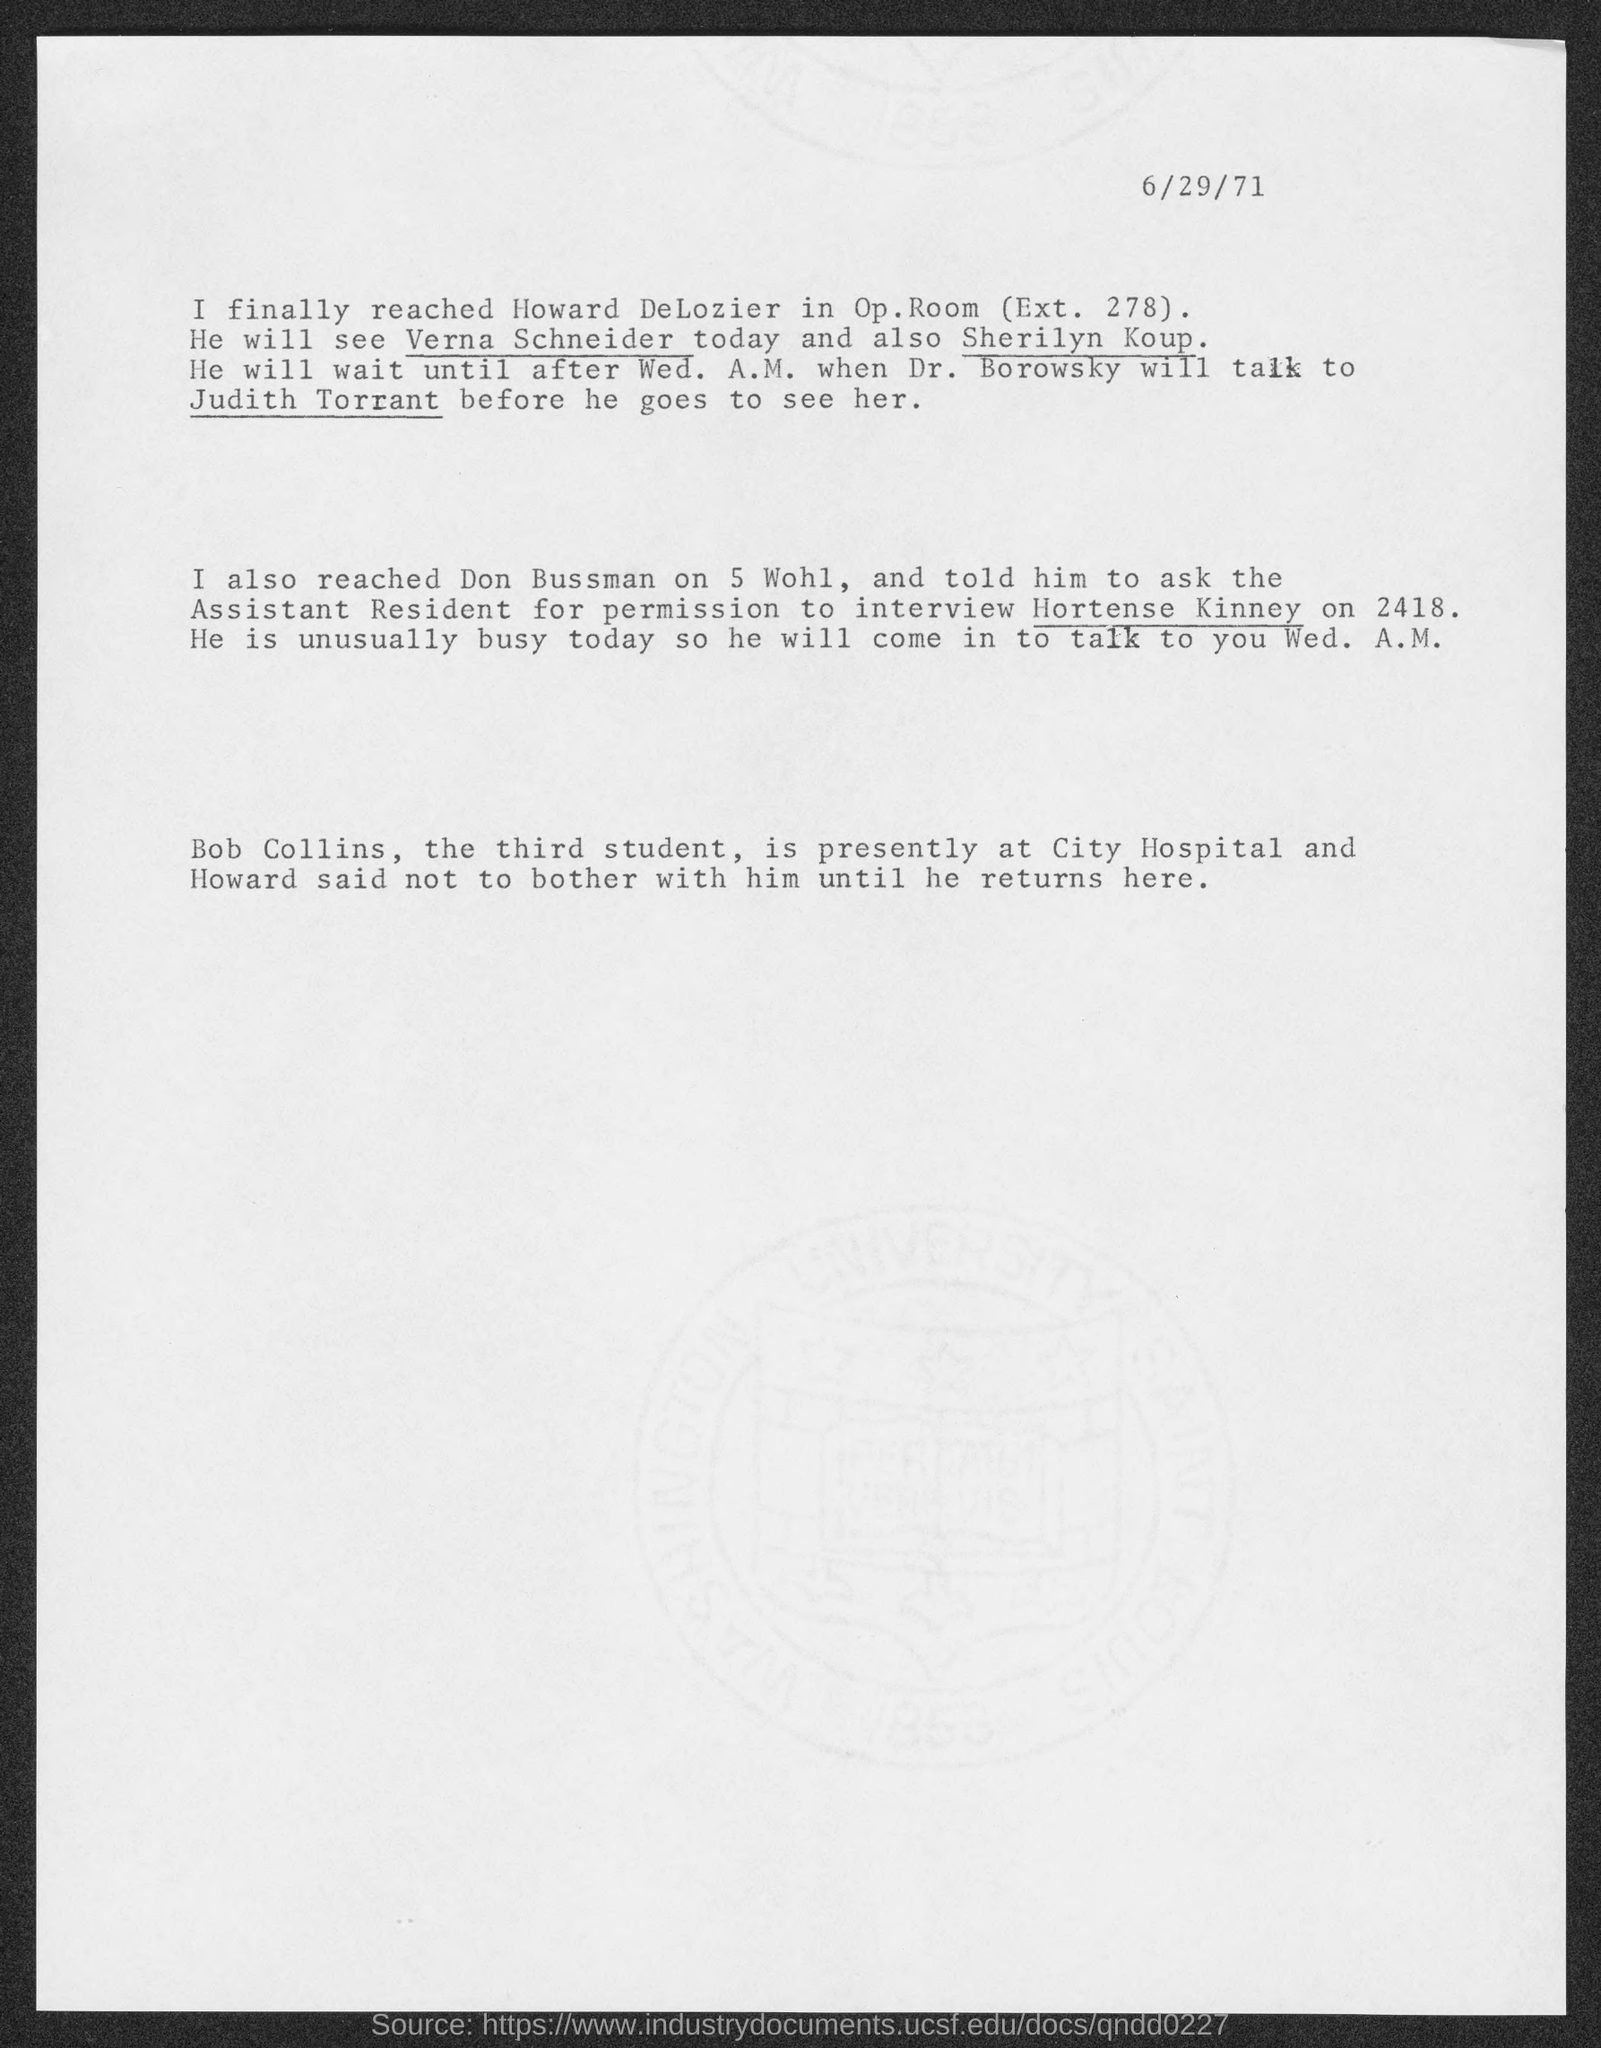Outline some significant characteristics in this image. The top-right corner of the page displays the date of June 29th, 1971. 